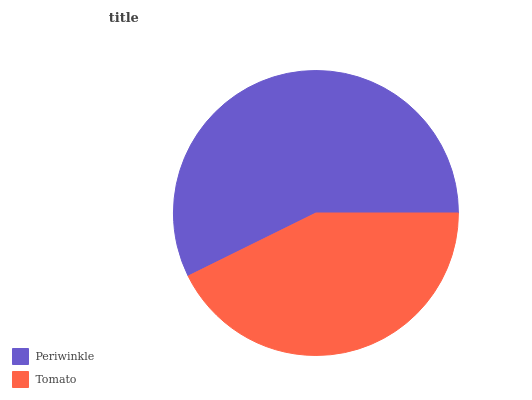Is Tomato the minimum?
Answer yes or no. Yes. Is Periwinkle the maximum?
Answer yes or no. Yes. Is Tomato the maximum?
Answer yes or no. No. Is Periwinkle greater than Tomato?
Answer yes or no. Yes. Is Tomato less than Periwinkle?
Answer yes or no. Yes. Is Tomato greater than Periwinkle?
Answer yes or no. No. Is Periwinkle less than Tomato?
Answer yes or no. No. Is Periwinkle the high median?
Answer yes or no. Yes. Is Tomato the low median?
Answer yes or no. Yes. Is Tomato the high median?
Answer yes or no. No. Is Periwinkle the low median?
Answer yes or no. No. 